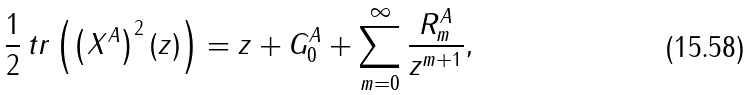Convert formula to latex. <formula><loc_0><loc_0><loc_500><loc_500>\frac { 1 } { 2 } \, t r \left ( \left ( X ^ { A } \right ) ^ { 2 } ( z ) \right ) = z + G ^ { A } _ { 0 } + \sum _ { m = 0 } ^ { \infty } \frac { R ^ { A } _ { m } } { z ^ { m + 1 } } ,</formula> 